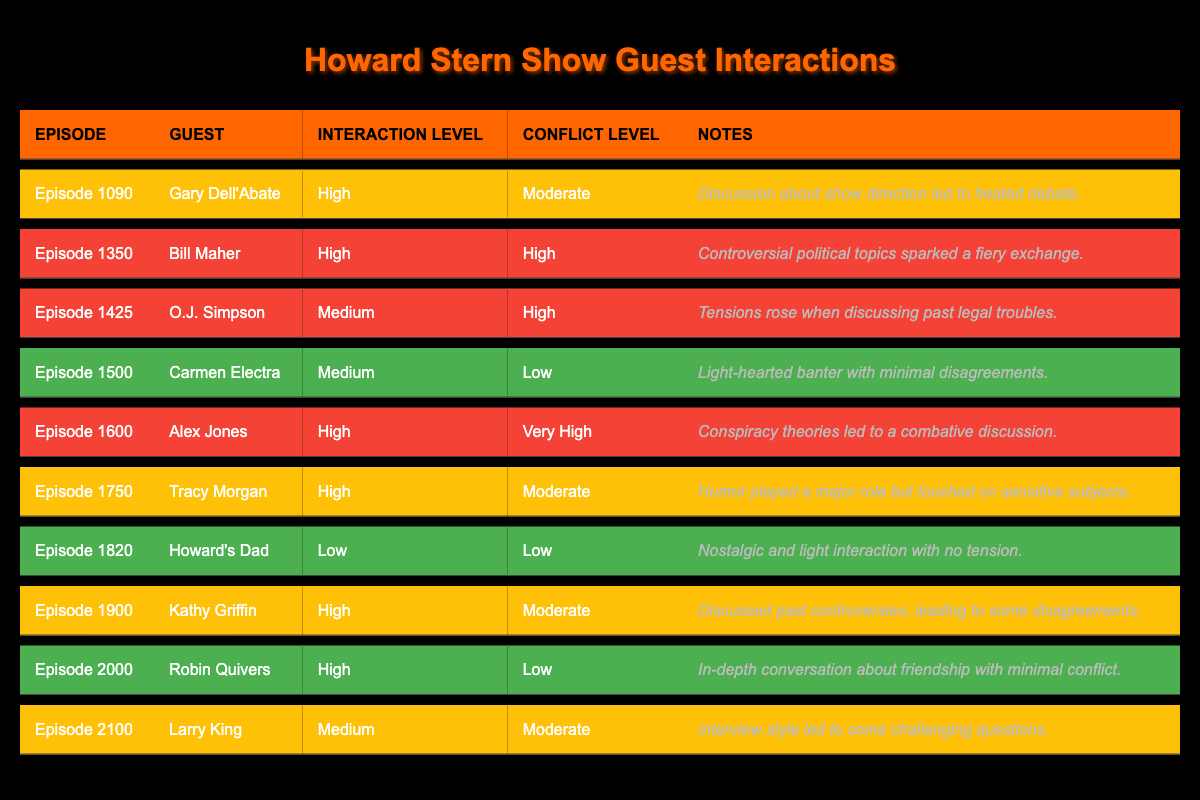What was the conflict level for Gary Dell'Abate's episode? According to the table, the conflict level for Gary Dell'Abate in Episode 1090 is "Moderate."
Answer: Moderate Which guest had the highest conflict level? In the table, Alex Jones in Episode 1600 has the highest conflict level, categorized as "Very High."
Answer: Very High What is the interaction level of Robin Quivers? For Episode 2000, Robin Quivers has an interaction level of "High."
Answer: High How many episodes featured guests with a high interaction level? By counting the episodes where the interaction level is "High," we find there are six such episodes: 1090, 1350, 1600, 1750, 1900, and 2000.
Answer: 6 Did any episode have a conflict level of "Low"? Yes, Episode 1500 with Carmen Electra and Episode 2000 with Robin Quivers both had a conflict level of "Low."
Answer: Yes What episode featured O.J. Simpson, and what was the conflict level? O.J. Simpson appeared in Episode 1425, where the conflict level is noted as "High."
Answer: Episode 1425, High Which guest had a moderate interaction level but a very high conflict level? In Episode 1600, Alex Jones had a high interaction level but is not noted for a moderate interaction level. Therefore, no guest fits this description.
Answer: None How many guests had a conflict level rated as "High"? Based on the data, there are three guests with a conflict level of "High": Bill Maher (Episode 1350), O.J. Simpson (Episode 1425), and Alex Jones (Episode 1600).
Answer: 3 Among the episodes with high interaction levels, which had the lowest conflict level? In checking the "High" interaction levels, Episode 2000 with Robin Quivers has the lowest conflict level categorized as "Low."
Answer: Episode 2000 Was there an episode where the interaction level was medium and the conflict level was high? Yes, Episode 1425 featuring O.J. Simpson has a medium interaction level with a high conflict level.
Answer: Yes 